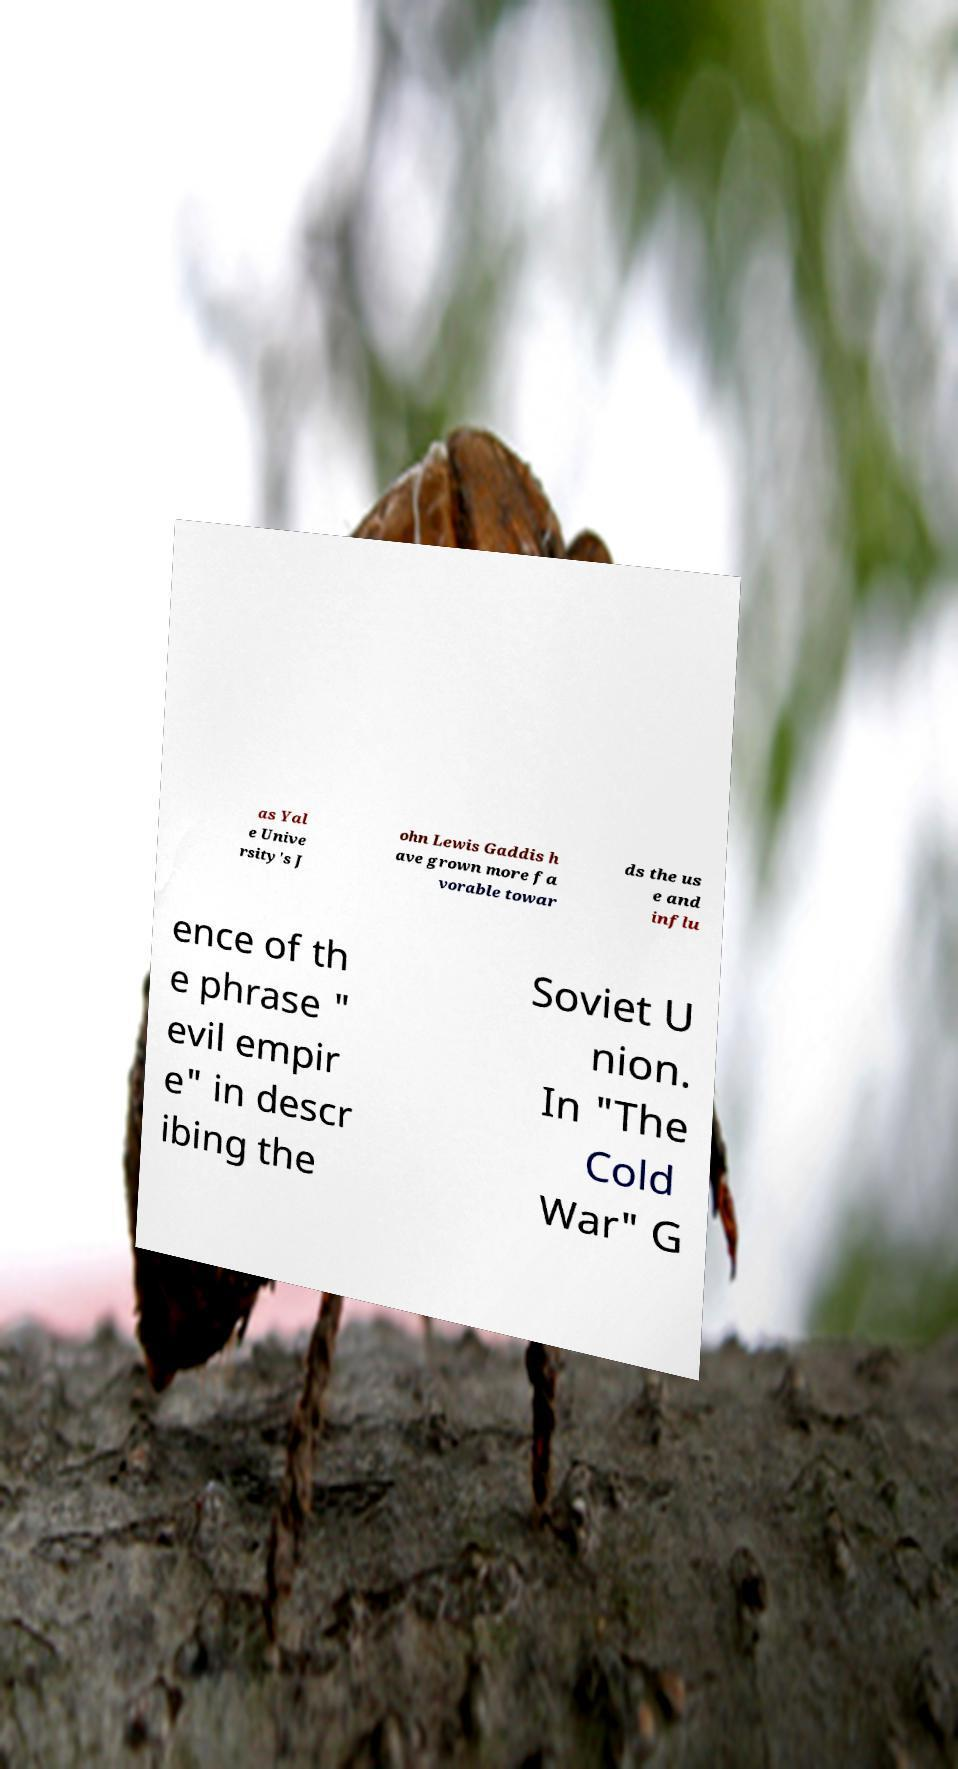Could you assist in decoding the text presented in this image and type it out clearly? as Yal e Unive rsity's J ohn Lewis Gaddis h ave grown more fa vorable towar ds the us e and influ ence of th e phrase " evil empir e" in descr ibing the Soviet U nion. In "The Cold War" G 